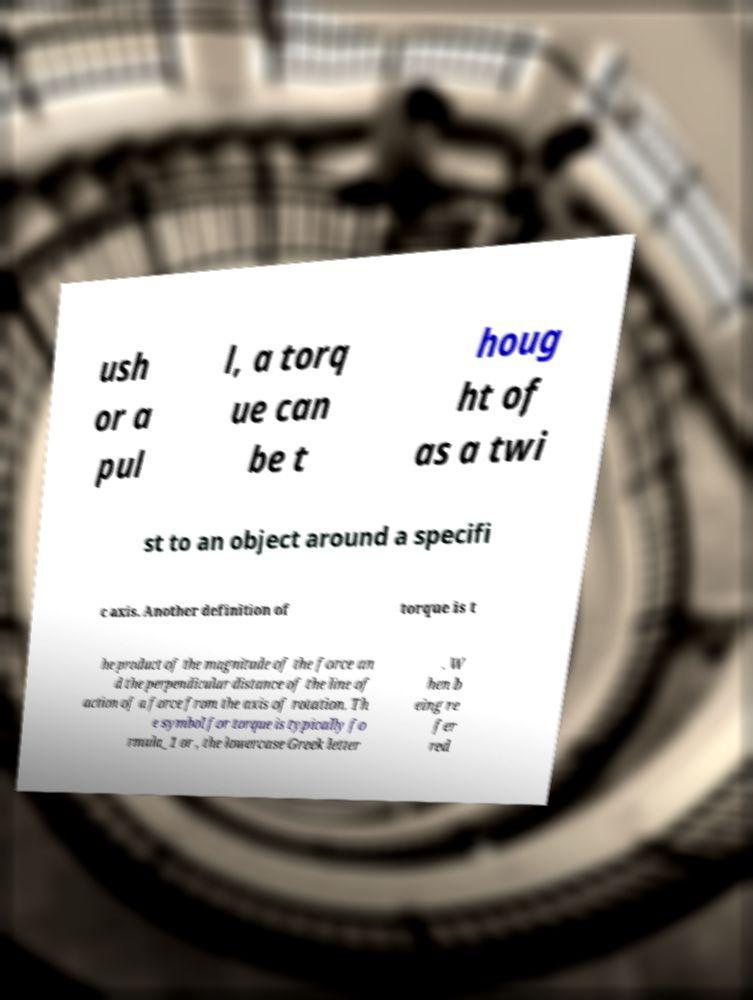I need the written content from this picture converted into text. Can you do that? ush or a pul l, a torq ue can be t houg ht of as a twi st to an object around a specifi c axis. Another definition of torque is t he product of the magnitude of the force an d the perpendicular distance of the line of action of a force from the axis of rotation. Th e symbol for torque is typically fo rmula_1 or , the lowercase Greek letter . W hen b eing re fer red 